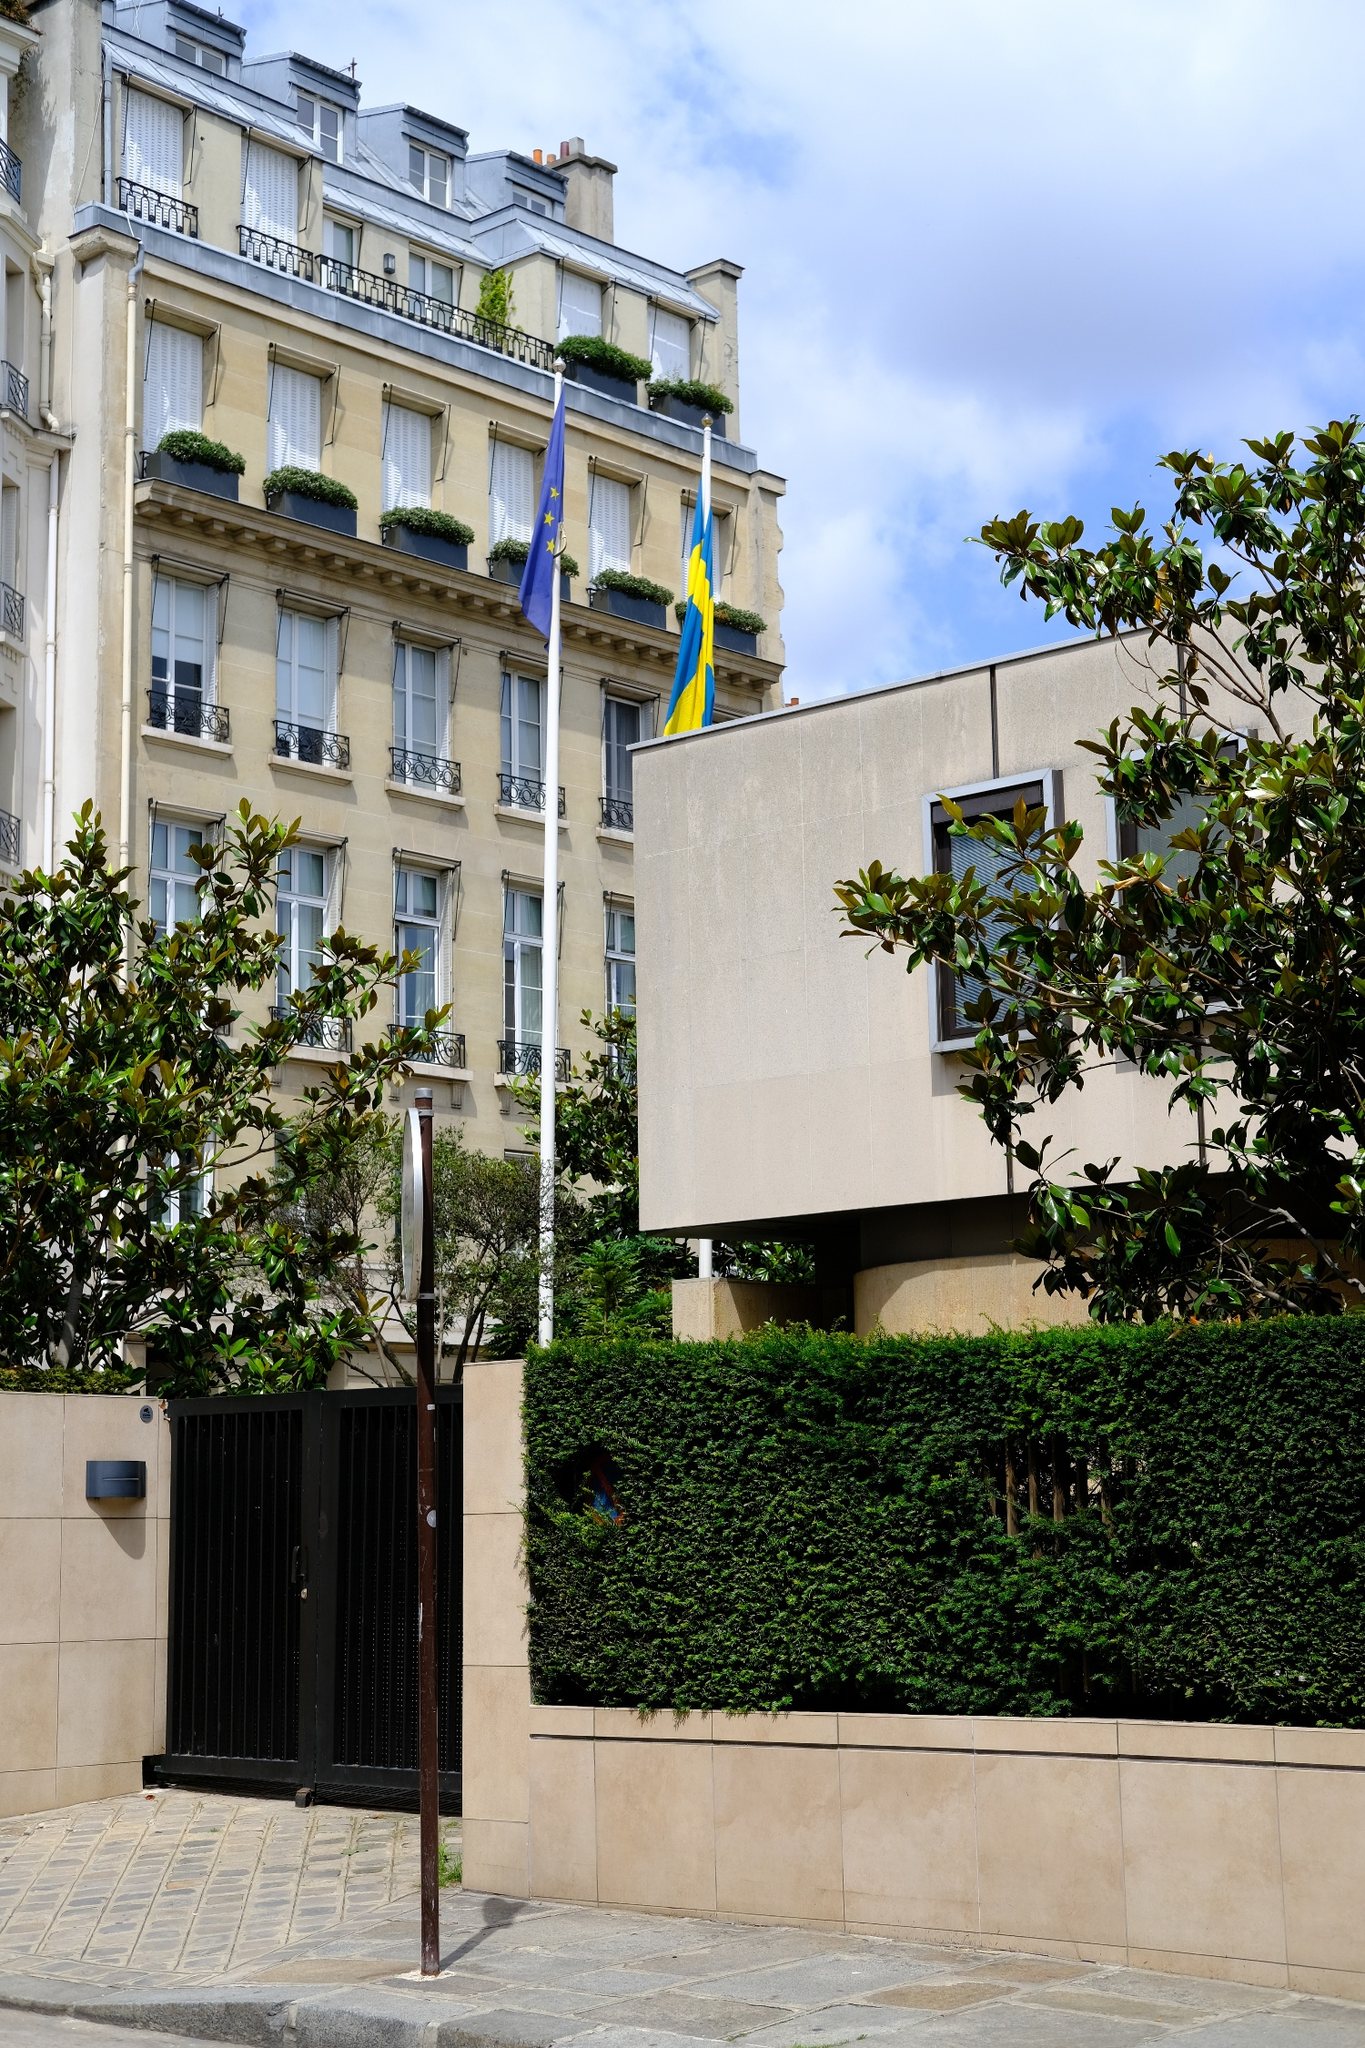Incorporate the elements you see into a fantastical tale. In a distant realm where magic and reality intertwine, this stately building was known as the Embassy of Merriment. Towering over the grand boulevard, adorned with cascading ivy and vibrant geraniums, it housed ancient secrets and mystical beings. Flags that symbolized unity and strength fluttered not in the wind but on their own accord, whispering ancient incantations to those who could listen. The building's exterior, though appearing mundane to most, was a portal to otherworldly dimensions. Every room within was enchanted—the large bay windows opened not to the street below but to vistas of enchanted forests, tranquil lakes under triple moons, and skies filled with dragon riders. This wasn’t merely a building; it was a nexus of worlds, where diplomats were wizards, and conversations held within could shift the balance between realms. Through its halls echoed the laughter of faeries, the wisdom of old sorcerers, and the music of the spheres. And thus, the seemingly ordinary scene concealed an epicenter of magic that governed the harmony of myriad universes. 